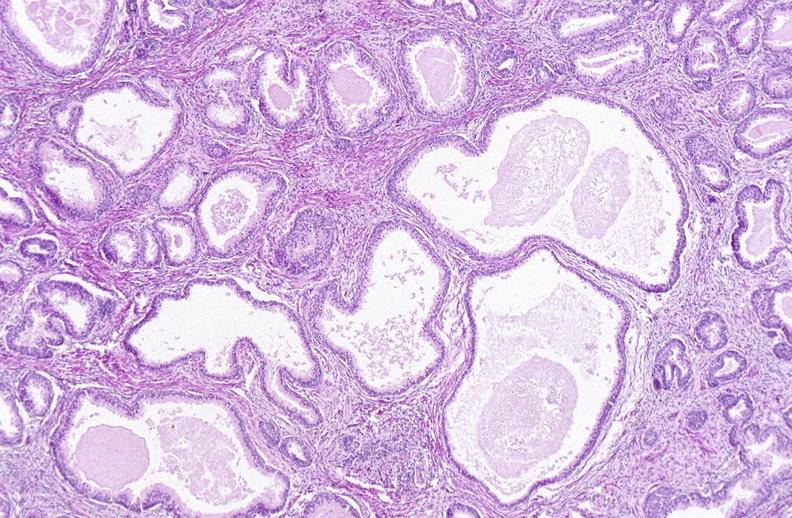what does this image show?
Answer the question using a single word or phrase. Prostate 